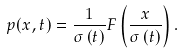Convert formula to latex. <formula><loc_0><loc_0><loc_500><loc_500>p ( x , t ) = \frac { 1 } { \sigma \left ( t \right ) } F \left ( \frac { x } { \sigma \left ( t \right ) } \right ) .</formula> 